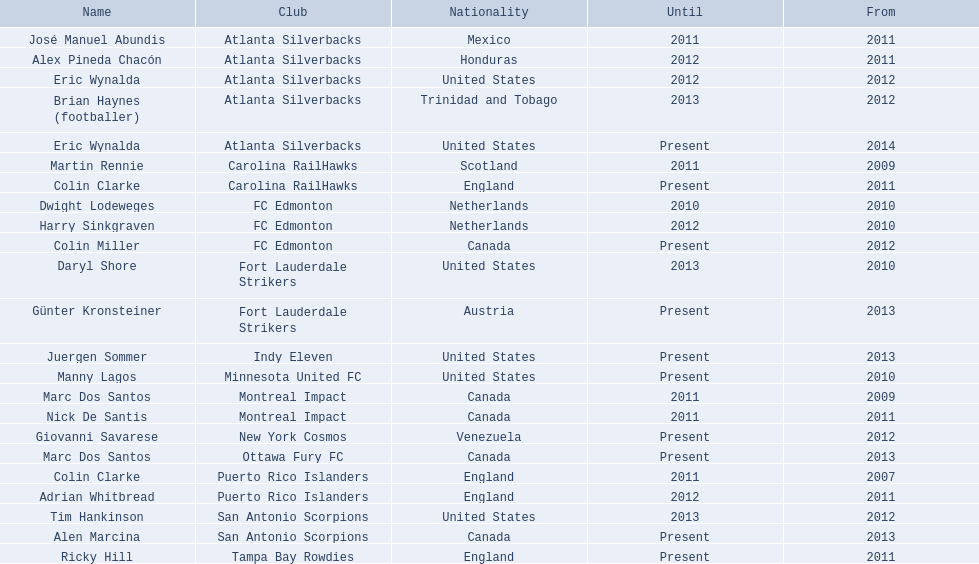What were all the coaches who were coaching in 2010? Martin Rennie, Dwight Lodeweges, Harry Sinkgraven, Daryl Shore, Manny Lagos, Marc Dos Santos, Colin Clarke. Which of the 2010 coaches were not born in north america? Martin Rennie, Dwight Lodeweges, Harry Sinkgraven, Colin Clarke. Which coaches that were coaching in 2010 and were not from north america did not coach for fc edmonton? Martin Rennie, Colin Clarke. What coach did not coach for fc edmonton in 2010 and was not north american nationality had the shortened career as a coach? Martin Rennie. 